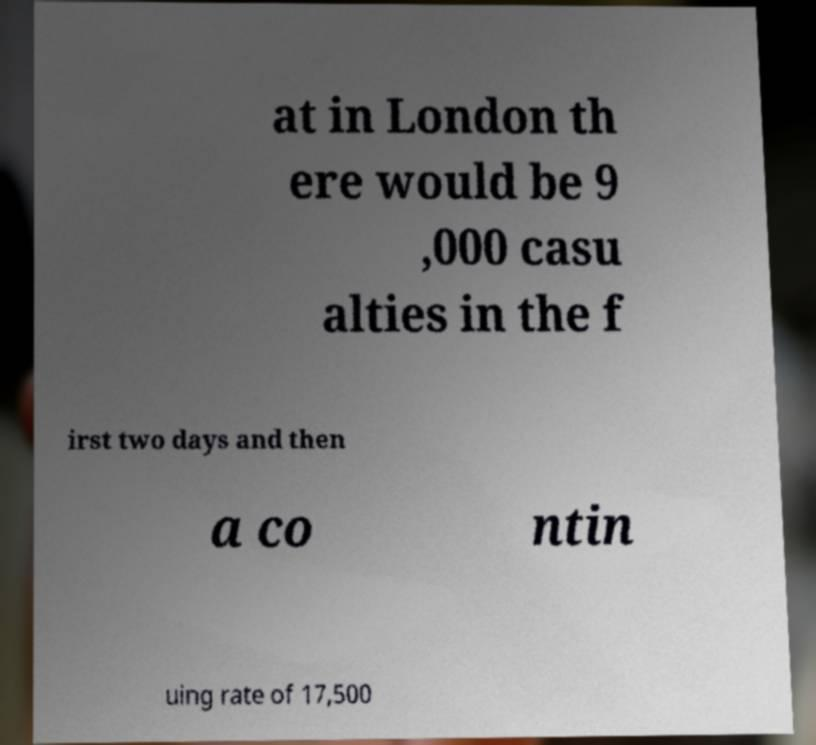Could you extract and type out the text from this image? at in London th ere would be 9 ,000 casu alties in the f irst two days and then a co ntin uing rate of 17,500 